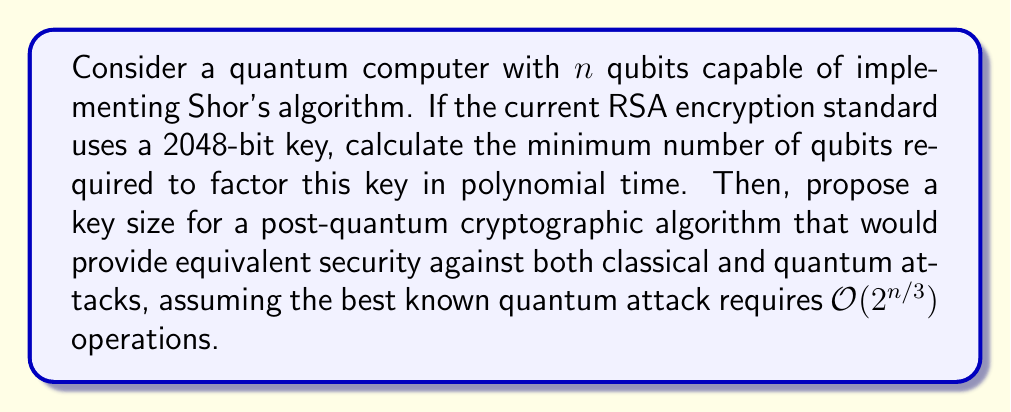Show me your answer to this math problem. 1. Shor's algorithm requires $2n + 2$ qubits to factor an $n$-bit number.

2. For a 2048-bit RSA key, we need to solve:
   $2n + 2 = 2048$
   $2n = 2046$
   $n = 1023$

3. Therefore, a quantum computer would need at least 1023 qubits to break the 2048-bit RSA key.

4. For post-quantum cryptography, we want to find a key size $m$ such that:
   $2^{m/3} \approx 2^{2048}$ (to match classical security)

5. Solving for $m$:
   $m/3 \approx 2048$
   $m \approx 2048 * 3 = 6144$

6. To ensure equivalent security against both classical and quantum attacks, we should use a key size of at least 6144 bits for a post-quantum cryptographic algorithm.

This approach demonstrates strategic thinking by assessing the current threat (quantum computing's impact on RSA) and proposing a forward-looking solution (increased key size for post-quantum algorithms) to improve the team's cryptographic security performance.
Answer: 1023 qubits; 6144-bit key 